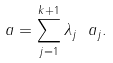Convert formula to latex. <formula><loc_0><loc_0><loc_500><loc_500>\ a = \sum _ { j = 1 } ^ { k + 1 } \lambda _ { j } \ a _ { j } .</formula> 